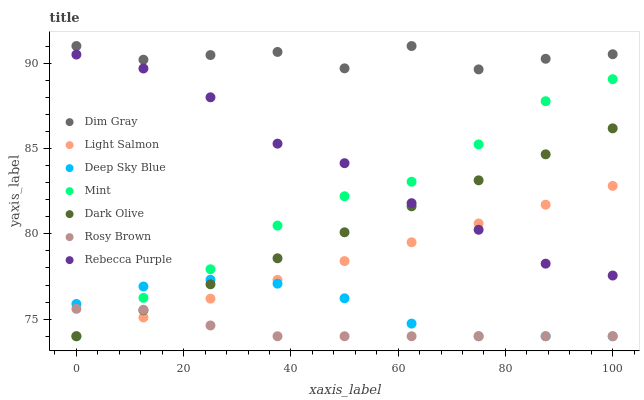Does Rosy Brown have the minimum area under the curve?
Answer yes or no. Yes. Does Dim Gray have the maximum area under the curve?
Answer yes or no. Yes. Does Dark Olive have the minimum area under the curve?
Answer yes or no. No. Does Dark Olive have the maximum area under the curve?
Answer yes or no. No. Is Light Salmon the smoothest?
Answer yes or no. Yes. Is Dim Gray the roughest?
Answer yes or no. Yes. Is Dark Olive the smoothest?
Answer yes or no. No. Is Dark Olive the roughest?
Answer yes or no. No. Does Light Salmon have the lowest value?
Answer yes or no. Yes. Does Dim Gray have the lowest value?
Answer yes or no. No. Does Dim Gray have the highest value?
Answer yes or no. Yes. Does Dark Olive have the highest value?
Answer yes or no. No. Is Dark Olive less than Dim Gray?
Answer yes or no. Yes. Is Dim Gray greater than Mint?
Answer yes or no. Yes. Does Rebecca Purple intersect Light Salmon?
Answer yes or no. Yes. Is Rebecca Purple less than Light Salmon?
Answer yes or no. No. Is Rebecca Purple greater than Light Salmon?
Answer yes or no. No. Does Dark Olive intersect Dim Gray?
Answer yes or no. No. 